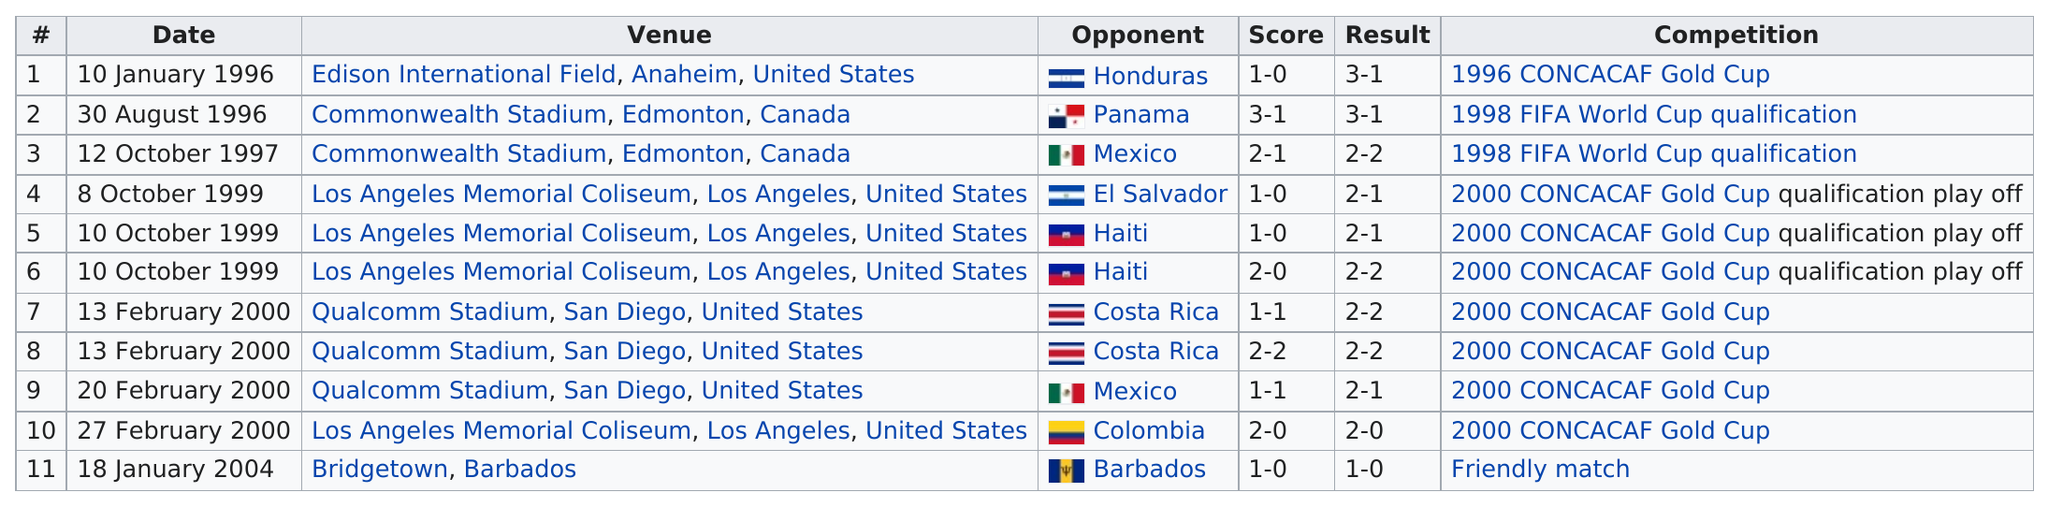Mention a couple of crucial points in this snapshot. The number of goals scored in Los Angeles was six. In the matches against Panama and Colombia, the team scored a combined total of 5 points. In the games where the combined score of both teams is at least 3, how many games were played? The latest match was played at Bridgetown, Barbados. In February 2000, the total number of games played was 4. 